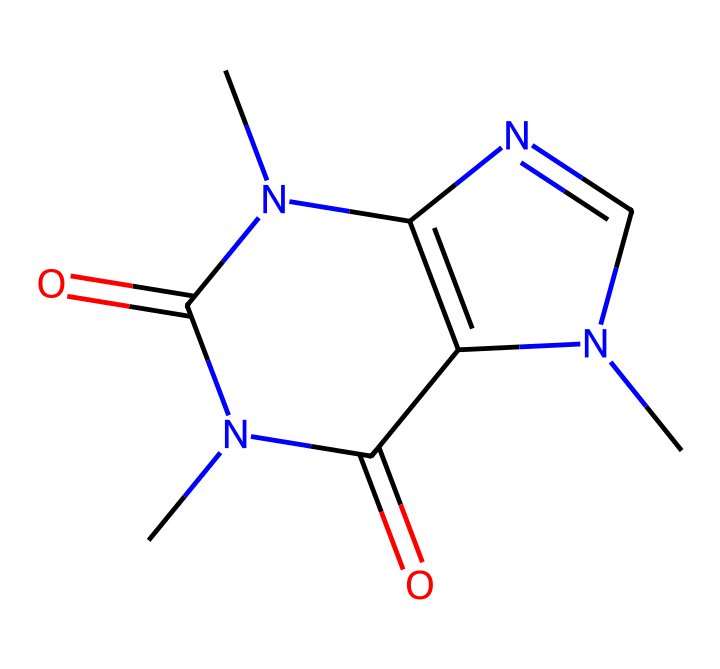How many nitrogen atoms are present in the caffeine structure? The SMILES representation indicates there are pieces of the structure that include nitrogen, specifically located in the rings and side chains. Counting these reveals a total of four nitrogen atoms.
Answer: four What is the functional group present in caffeine? In the structure provided, the carbonyls (C=O) represent the presence of amide functional groups, as there are two carbonyl groups attached to nitrogen atoms in the chemical.
Answer: amide What type of compound is caffeine classified as? Caffeine is classified as an alkaloid due to the presence of multiple nitrogen atoms in its structure which are characteristic of this type of compound.
Answer: alkaloid What is the total number of rings in the caffeine structure? By analyzing the structure composed of connected cyclic areas, one can see that there are two distinct rings in the structure when visualized clearly.
Answer: two Which part of the structure indicates it has psychoactive effects? The presence of nitrogen atoms within rings and their connection to the rest of the structure is characteristic of many psychoactive compounds, including caffeine.
Answer: nitrogen atoms How many carbonyl (C=O) groups are present in the caffeine structure? The SMILES indicates specific positions where double-bonded oxygen is present adjacent to nitrogen. In total, there are two carbonyl groups visible in the structure.
Answer: two 